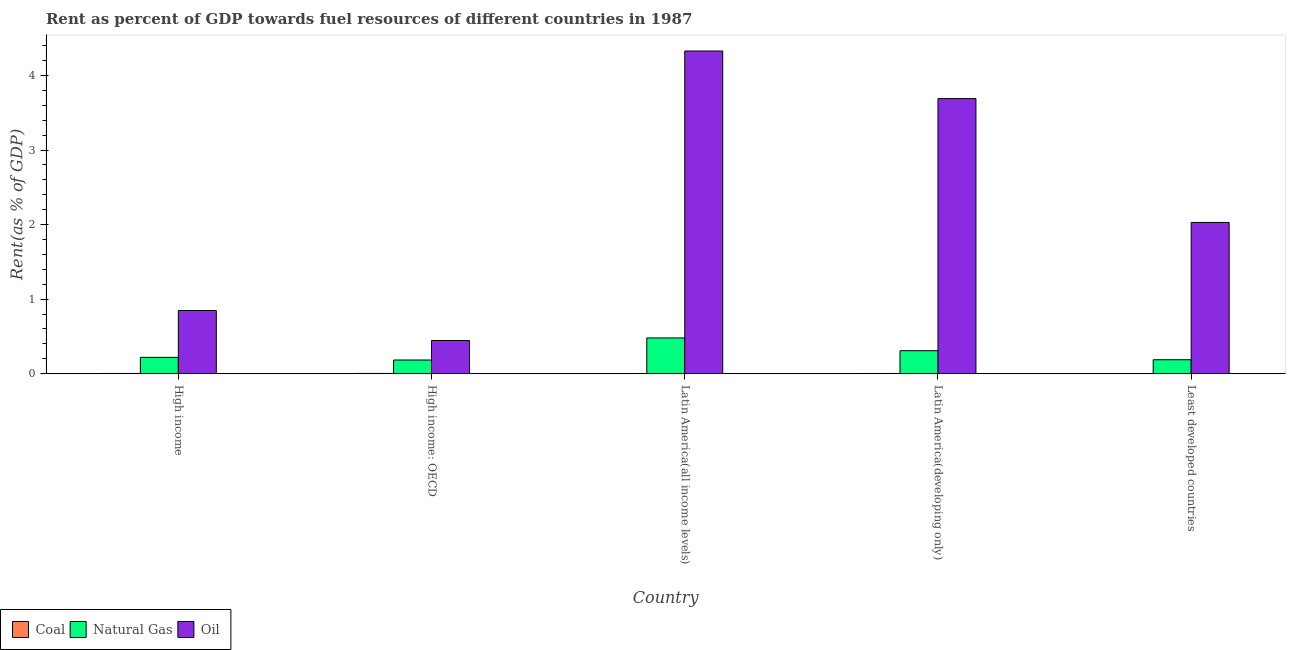How many groups of bars are there?
Your answer should be compact. 5. What is the label of the 2nd group of bars from the left?
Provide a succinct answer. High income: OECD. In how many cases, is the number of bars for a given country not equal to the number of legend labels?
Keep it short and to the point. 0. What is the rent towards natural gas in Least developed countries?
Ensure brevity in your answer.  0.19. Across all countries, what is the maximum rent towards coal?
Give a very brief answer. 0. Across all countries, what is the minimum rent towards natural gas?
Offer a terse response. 0.18. In which country was the rent towards natural gas maximum?
Make the answer very short. Latin America(all income levels). In which country was the rent towards oil minimum?
Offer a terse response. High income: OECD. What is the total rent towards natural gas in the graph?
Provide a short and direct response. 1.38. What is the difference between the rent towards coal in High income and that in High income: OECD?
Your response must be concise. -0. What is the difference between the rent towards coal in Latin America(developing only) and the rent towards natural gas in High income?
Your answer should be compact. -0.22. What is the average rent towards natural gas per country?
Make the answer very short. 0.28. What is the difference between the rent towards coal and rent towards oil in Latin America(all income levels)?
Ensure brevity in your answer.  -4.33. In how many countries, is the rent towards oil greater than 1.2 %?
Give a very brief answer. 3. What is the ratio of the rent towards natural gas in High income to that in High income: OECD?
Your answer should be compact. 1.19. Is the difference between the rent towards oil in High income and Latin America(all income levels) greater than the difference between the rent towards coal in High income and Latin America(all income levels)?
Make the answer very short. No. What is the difference between the highest and the second highest rent towards oil?
Provide a short and direct response. 0.64. What is the difference between the highest and the lowest rent towards oil?
Your answer should be compact. 3.88. In how many countries, is the rent towards oil greater than the average rent towards oil taken over all countries?
Make the answer very short. 2. What does the 1st bar from the left in High income: OECD represents?
Keep it short and to the point. Coal. What does the 1st bar from the right in High income: OECD represents?
Provide a succinct answer. Oil. Is it the case that in every country, the sum of the rent towards coal and rent towards natural gas is greater than the rent towards oil?
Offer a terse response. No. How many bars are there?
Your response must be concise. 15. How many countries are there in the graph?
Give a very brief answer. 5. Does the graph contain any zero values?
Ensure brevity in your answer.  No. Where does the legend appear in the graph?
Ensure brevity in your answer.  Bottom left. How are the legend labels stacked?
Give a very brief answer. Horizontal. What is the title of the graph?
Provide a short and direct response. Rent as percent of GDP towards fuel resources of different countries in 1987. Does "Czech Republic" appear as one of the legend labels in the graph?
Offer a terse response. No. What is the label or title of the X-axis?
Offer a terse response. Country. What is the label or title of the Y-axis?
Provide a short and direct response. Rent(as % of GDP). What is the Rent(as % of GDP) in Coal in High income?
Provide a short and direct response. 0. What is the Rent(as % of GDP) in Natural Gas in High income?
Make the answer very short. 0.22. What is the Rent(as % of GDP) of Oil in High income?
Give a very brief answer. 0.85. What is the Rent(as % of GDP) in Coal in High income: OECD?
Your response must be concise. 0. What is the Rent(as % of GDP) of Natural Gas in High income: OECD?
Give a very brief answer. 0.18. What is the Rent(as % of GDP) of Oil in High income: OECD?
Make the answer very short. 0.45. What is the Rent(as % of GDP) in Coal in Latin America(all income levels)?
Your response must be concise. 0. What is the Rent(as % of GDP) of Natural Gas in Latin America(all income levels)?
Keep it short and to the point. 0.48. What is the Rent(as % of GDP) of Oil in Latin America(all income levels)?
Provide a short and direct response. 4.33. What is the Rent(as % of GDP) of Coal in Latin America(developing only)?
Give a very brief answer. 0. What is the Rent(as % of GDP) of Natural Gas in Latin America(developing only)?
Keep it short and to the point. 0.31. What is the Rent(as % of GDP) of Oil in Latin America(developing only)?
Ensure brevity in your answer.  3.69. What is the Rent(as % of GDP) of Coal in Least developed countries?
Your answer should be compact. 5.84697420507121e-6. What is the Rent(as % of GDP) in Natural Gas in Least developed countries?
Ensure brevity in your answer.  0.19. What is the Rent(as % of GDP) of Oil in Least developed countries?
Your answer should be compact. 2.03. Across all countries, what is the maximum Rent(as % of GDP) in Coal?
Your response must be concise. 0. Across all countries, what is the maximum Rent(as % of GDP) of Natural Gas?
Ensure brevity in your answer.  0.48. Across all countries, what is the maximum Rent(as % of GDP) in Oil?
Your response must be concise. 4.33. Across all countries, what is the minimum Rent(as % of GDP) in Coal?
Offer a terse response. 5.84697420507121e-6. Across all countries, what is the minimum Rent(as % of GDP) of Natural Gas?
Your answer should be compact. 0.18. Across all countries, what is the minimum Rent(as % of GDP) in Oil?
Offer a very short reply. 0.45. What is the total Rent(as % of GDP) of Coal in the graph?
Ensure brevity in your answer.  0.01. What is the total Rent(as % of GDP) of Natural Gas in the graph?
Your answer should be compact. 1.38. What is the total Rent(as % of GDP) in Oil in the graph?
Your response must be concise. 11.34. What is the difference between the Rent(as % of GDP) in Coal in High income and that in High income: OECD?
Make the answer very short. -0. What is the difference between the Rent(as % of GDP) of Natural Gas in High income and that in High income: OECD?
Give a very brief answer. 0.04. What is the difference between the Rent(as % of GDP) of Oil in High income and that in High income: OECD?
Keep it short and to the point. 0.4. What is the difference between the Rent(as % of GDP) of Coal in High income and that in Latin America(all income levels)?
Give a very brief answer. 0. What is the difference between the Rent(as % of GDP) of Natural Gas in High income and that in Latin America(all income levels)?
Your answer should be very brief. -0.26. What is the difference between the Rent(as % of GDP) in Oil in High income and that in Latin America(all income levels)?
Your answer should be compact. -3.48. What is the difference between the Rent(as % of GDP) of Natural Gas in High income and that in Latin America(developing only)?
Your response must be concise. -0.09. What is the difference between the Rent(as % of GDP) in Oil in High income and that in Latin America(developing only)?
Keep it short and to the point. -2.84. What is the difference between the Rent(as % of GDP) of Coal in High income and that in Least developed countries?
Offer a very short reply. 0. What is the difference between the Rent(as % of GDP) in Natural Gas in High income and that in Least developed countries?
Keep it short and to the point. 0.03. What is the difference between the Rent(as % of GDP) in Oil in High income and that in Least developed countries?
Offer a terse response. -1.18. What is the difference between the Rent(as % of GDP) in Coal in High income: OECD and that in Latin America(all income levels)?
Keep it short and to the point. 0. What is the difference between the Rent(as % of GDP) in Natural Gas in High income: OECD and that in Latin America(all income levels)?
Your response must be concise. -0.3. What is the difference between the Rent(as % of GDP) of Oil in High income: OECD and that in Latin America(all income levels)?
Make the answer very short. -3.88. What is the difference between the Rent(as % of GDP) of Coal in High income: OECD and that in Latin America(developing only)?
Keep it short and to the point. 0. What is the difference between the Rent(as % of GDP) of Natural Gas in High income: OECD and that in Latin America(developing only)?
Ensure brevity in your answer.  -0.12. What is the difference between the Rent(as % of GDP) of Oil in High income: OECD and that in Latin America(developing only)?
Your answer should be compact. -3.24. What is the difference between the Rent(as % of GDP) of Coal in High income: OECD and that in Least developed countries?
Give a very brief answer. 0. What is the difference between the Rent(as % of GDP) of Natural Gas in High income: OECD and that in Least developed countries?
Your answer should be very brief. -0. What is the difference between the Rent(as % of GDP) of Oil in High income: OECD and that in Least developed countries?
Your response must be concise. -1.58. What is the difference between the Rent(as % of GDP) in Coal in Latin America(all income levels) and that in Latin America(developing only)?
Offer a very short reply. -0. What is the difference between the Rent(as % of GDP) of Natural Gas in Latin America(all income levels) and that in Latin America(developing only)?
Offer a terse response. 0.17. What is the difference between the Rent(as % of GDP) in Oil in Latin America(all income levels) and that in Latin America(developing only)?
Offer a terse response. 0.64. What is the difference between the Rent(as % of GDP) of Coal in Latin America(all income levels) and that in Least developed countries?
Your answer should be compact. 0. What is the difference between the Rent(as % of GDP) of Natural Gas in Latin America(all income levels) and that in Least developed countries?
Your answer should be compact. 0.29. What is the difference between the Rent(as % of GDP) of Oil in Latin America(all income levels) and that in Least developed countries?
Provide a succinct answer. 2.3. What is the difference between the Rent(as % of GDP) of Coal in Latin America(developing only) and that in Least developed countries?
Give a very brief answer. 0. What is the difference between the Rent(as % of GDP) in Natural Gas in Latin America(developing only) and that in Least developed countries?
Ensure brevity in your answer.  0.12. What is the difference between the Rent(as % of GDP) in Oil in Latin America(developing only) and that in Least developed countries?
Your response must be concise. 1.66. What is the difference between the Rent(as % of GDP) in Coal in High income and the Rent(as % of GDP) in Natural Gas in High income: OECD?
Your answer should be very brief. -0.18. What is the difference between the Rent(as % of GDP) of Coal in High income and the Rent(as % of GDP) of Oil in High income: OECD?
Your answer should be compact. -0.44. What is the difference between the Rent(as % of GDP) of Natural Gas in High income and the Rent(as % of GDP) of Oil in High income: OECD?
Your response must be concise. -0.23. What is the difference between the Rent(as % of GDP) of Coal in High income and the Rent(as % of GDP) of Natural Gas in Latin America(all income levels)?
Keep it short and to the point. -0.48. What is the difference between the Rent(as % of GDP) of Coal in High income and the Rent(as % of GDP) of Oil in Latin America(all income levels)?
Give a very brief answer. -4.32. What is the difference between the Rent(as % of GDP) of Natural Gas in High income and the Rent(as % of GDP) of Oil in Latin America(all income levels)?
Offer a very short reply. -4.11. What is the difference between the Rent(as % of GDP) of Coal in High income and the Rent(as % of GDP) of Natural Gas in Latin America(developing only)?
Provide a succinct answer. -0.3. What is the difference between the Rent(as % of GDP) in Coal in High income and the Rent(as % of GDP) in Oil in Latin America(developing only)?
Offer a very short reply. -3.69. What is the difference between the Rent(as % of GDP) in Natural Gas in High income and the Rent(as % of GDP) in Oil in Latin America(developing only)?
Provide a succinct answer. -3.47. What is the difference between the Rent(as % of GDP) in Coal in High income and the Rent(as % of GDP) in Natural Gas in Least developed countries?
Keep it short and to the point. -0.18. What is the difference between the Rent(as % of GDP) in Coal in High income and the Rent(as % of GDP) in Oil in Least developed countries?
Your answer should be compact. -2.03. What is the difference between the Rent(as % of GDP) in Natural Gas in High income and the Rent(as % of GDP) in Oil in Least developed countries?
Ensure brevity in your answer.  -1.81. What is the difference between the Rent(as % of GDP) in Coal in High income: OECD and the Rent(as % of GDP) in Natural Gas in Latin America(all income levels)?
Provide a short and direct response. -0.48. What is the difference between the Rent(as % of GDP) of Coal in High income: OECD and the Rent(as % of GDP) of Oil in Latin America(all income levels)?
Your answer should be very brief. -4.32. What is the difference between the Rent(as % of GDP) in Natural Gas in High income: OECD and the Rent(as % of GDP) in Oil in Latin America(all income levels)?
Ensure brevity in your answer.  -4.14. What is the difference between the Rent(as % of GDP) in Coal in High income: OECD and the Rent(as % of GDP) in Natural Gas in Latin America(developing only)?
Keep it short and to the point. -0.3. What is the difference between the Rent(as % of GDP) of Coal in High income: OECD and the Rent(as % of GDP) of Oil in Latin America(developing only)?
Offer a very short reply. -3.69. What is the difference between the Rent(as % of GDP) in Natural Gas in High income: OECD and the Rent(as % of GDP) in Oil in Latin America(developing only)?
Provide a succinct answer. -3.51. What is the difference between the Rent(as % of GDP) in Coal in High income: OECD and the Rent(as % of GDP) in Natural Gas in Least developed countries?
Provide a short and direct response. -0.18. What is the difference between the Rent(as % of GDP) in Coal in High income: OECD and the Rent(as % of GDP) in Oil in Least developed countries?
Ensure brevity in your answer.  -2.02. What is the difference between the Rent(as % of GDP) in Natural Gas in High income: OECD and the Rent(as % of GDP) in Oil in Least developed countries?
Offer a terse response. -1.84. What is the difference between the Rent(as % of GDP) in Coal in Latin America(all income levels) and the Rent(as % of GDP) in Natural Gas in Latin America(developing only)?
Offer a terse response. -0.31. What is the difference between the Rent(as % of GDP) of Coal in Latin America(all income levels) and the Rent(as % of GDP) of Oil in Latin America(developing only)?
Your answer should be very brief. -3.69. What is the difference between the Rent(as % of GDP) of Natural Gas in Latin America(all income levels) and the Rent(as % of GDP) of Oil in Latin America(developing only)?
Keep it short and to the point. -3.21. What is the difference between the Rent(as % of GDP) of Coal in Latin America(all income levels) and the Rent(as % of GDP) of Natural Gas in Least developed countries?
Your answer should be very brief. -0.19. What is the difference between the Rent(as % of GDP) of Coal in Latin America(all income levels) and the Rent(as % of GDP) of Oil in Least developed countries?
Your answer should be very brief. -2.03. What is the difference between the Rent(as % of GDP) in Natural Gas in Latin America(all income levels) and the Rent(as % of GDP) in Oil in Least developed countries?
Ensure brevity in your answer.  -1.55. What is the difference between the Rent(as % of GDP) in Coal in Latin America(developing only) and the Rent(as % of GDP) in Natural Gas in Least developed countries?
Provide a short and direct response. -0.18. What is the difference between the Rent(as % of GDP) in Coal in Latin America(developing only) and the Rent(as % of GDP) in Oil in Least developed countries?
Offer a very short reply. -2.03. What is the difference between the Rent(as % of GDP) of Natural Gas in Latin America(developing only) and the Rent(as % of GDP) of Oil in Least developed countries?
Offer a terse response. -1.72. What is the average Rent(as % of GDP) of Coal per country?
Provide a succinct answer. 0. What is the average Rent(as % of GDP) of Natural Gas per country?
Provide a short and direct response. 0.28. What is the average Rent(as % of GDP) in Oil per country?
Offer a terse response. 2.27. What is the difference between the Rent(as % of GDP) in Coal and Rent(as % of GDP) in Natural Gas in High income?
Give a very brief answer. -0.22. What is the difference between the Rent(as % of GDP) of Coal and Rent(as % of GDP) of Oil in High income?
Keep it short and to the point. -0.84. What is the difference between the Rent(as % of GDP) of Natural Gas and Rent(as % of GDP) of Oil in High income?
Give a very brief answer. -0.63. What is the difference between the Rent(as % of GDP) in Coal and Rent(as % of GDP) in Natural Gas in High income: OECD?
Make the answer very short. -0.18. What is the difference between the Rent(as % of GDP) of Coal and Rent(as % of GDP) of Oil in High income: OECD?
Ensure brevity in your answer.  -0.44. What is the difference between the Rent(as % of GDP) in Natural Gas and Rent(as % of GDP) in Oil in High income: OECD?
Your response must be concise. -0.26. What is the difference between the Rent(as % of GDP) in Coal and Rent(as % of GDP) in Natural Gas in Latin America(all income levels)?
Ensure brevity in your answer.  -0.48. What is the difference between the Rent(as % of GDP) in Coal and Rent(as % of GDP) in Oil in Latin America(all income levels)?
Offer a very short reply. -4.33. What is the difference between the Rent(as % of GDP) in Natural Gas and Rent(as % of GDP) in Oil in Latin America(all income levels)?
Your answer should be compact. -3.85. What is the difference between the Rent(as % of GDP) in Coal and Rent(as % of GDP) in Natural Gas in Latin America(developing only)?
Offer a very short reply. -0.31. What is the difference between the Rent(as % of GDP) of Coal and Rent(as % of GDP) of Oil in Latin America(developing only)?
Provide a succinct answer. -3.69. What is the difference between the Rent(as % of GDP) in Natural Gas and Rent(as % of GDP) in Oil in Latin America(developing only)?
Offer a terse response. -3.38. What is the difference between the Rent(as % of GDP) of Coal and Rent(as % of GDP) of Natural Gas in Least developed countries?
Keep it short and to the point. -0.19. What is the difference between the Rent(as % of GDP) of Coal and Rent(as % of GDP) of Oil in Least developed countries?
Provide a succinct answer. -2.03. What is the difference between the Rent(as % of GDP) of Natural Gas and Rent(as % of GDP) of Oil in Least developed countries?
Keep it short and to the point. -1.84. What is the ratio of the Rent(as % of GDP) in Coal in High income to that in High income: OECD?
Your answer should be very brief. 0.96. What is the ratio of the Rent(as % of GDP) in Natural Gas in High income to that in High income: OECD?
Offer a terse response. 1.19. What is the ratio of the Rent(as % of GDP) of Oil in High income to that in High income: OECD?
Make the answer very short. 1.9. What is the ratio of the Rent(as % of GDP) in Coal in High income to that in Latin America(all income levels)?
Provide a succinct answer. 1.57. What is the ratio of the Rent(as % of GDP) of Natural Gas in High income to that in Latin America(all income levels)?
Provide a succinct answer. 0.46. What is the ratio of the Rent(as % of GDP) of Oil in High income to that in Latin America(all income levels)?
Your response must be concise. 0.2. What is the ratio of the Rent(as % of GDP) of Coal in High income to that in Latin America(developing only)?
Provide a short and direct response. 1.14. What is the ratio of the Rent(as % of GDP) in Natural Gas in High income to that in Latin America(developing only)?
Your response must be concise. 0.71. What is the ratio of the Rent(as % of GDP) in Oil in High income to that in Latin America(developing only)?
Provide a short and direct response. 0.23. What is the ratio of the Rent(as % of GDP) of Coal in High income to that in Least developed countries?
Your answer should be very brief. 668.19. What is the ratio of the Rent(as % of GDP) of Natural Gas in High income to that in Least developed countries?
Provide a succinct answer. 1.17. What is the ratio of the Rent(as % of GDP) of Oil in High income to that in Least developed countries?
Your response must be concise. 0.42. What is the ratio of the Rent(as % of GDP) of Coal in High income: OECD to that in Latin America(all income levels)?
Your response must be concise. 1.64. What is the ratio of the Rent(as % of GDP) in Natural Gas in High income: OECD to that in Latin America(all income levels)?
Give a very brief answer. 0.38. What is the ratio of the Rent(as % of GDP) of Oil in High income: OECD to that in Latin America(all income levels)?
Provide a succinct answer. 0.1. What is the ratio of the Rent(as % of GDP) of Coal in High income: OECD to that in Latin America(developing only)?
Ensure brevity in your answer.  1.19. What is the ratio of the Rent(as % of GDP) in Natural Gas in High income: OECD to that in Latin America(developing only)?
Your response must be concise. 0.6. What is the ratio of the Rent(as % of GDP) in Oil in High income: OECD to that in Latin America(developing only)?
Give a very brief answer. 0.12. What is the ratio of the Rent(as % of GDP) in Coal in High income: OECD to that in Least developed countries?
Give a very brief answer. 695.39. What is the ratio of the Rent(as % of GDP) of Oil in High income: OECD to that in Least developed countries?
Your response must be concise. 0.22. What is the ratio of the Rent(as % of GDP) in Coal in Latin America(all income levels) to that in Latin America(developing only)?
Your answer should be compact. 0.73. What is the ratio of the Rent(as % of GDP) of Natural Gas in Latin America(all income levels) to that in Latin America(developing only)?
Provide a short and direct response. 1.55. What is the ratio of the Rent(as % of GDP) of Oil in Latin America(all income levels) to that in Latin America(developing only)?
Offer a very short reply. 1.17. What is the ratio of the Rent(as % of GDP) in Coal in Latin America(all income levels) to that in Least developed countries?
Your answer should be very brief. 425.18. What is the ratio of the Rent(as % of GDP) in Natural Gas in Latin America(all income levels) to that in Least developed countries?
Give a very brief answer. 2.56. What is the ratio of the Rent(as % of GDP) in Oil in Latin America(all income levels) to that in Least developed countries?
Your answer should be very brief. 2.13. What is the ratio of the Rent(as % of GDP) of Coal in Latin America(developing only) to that in Least developed countries?
Your answer should be compact. 585.97. What is the ratio of the Rent(as % of GDP) in Natural Gas in Latin America(developing only) to that in Least developed countries?
Ensure brevity in your answer.  1.64. What is the ratio of the Rent(as % of GDP) in Oil in Latin America(developing only) to that in Least developed countries?
Give a very brief answer. 1.82. What is the difference between the highest and the second highest Rent(as % of GDP) in Coal?
Your answer should be compact. 0. What is the difference between the highest and the second highest Rent(as % of GDP) in Natural Gas?
Offer a very short reply. 0.17. What is the difference between the highest and the second highest Rent(as % of GDP) in Oil?
Provide a succinct answer. 0.64. What is the difference between the highest and the lowest Rent(as % of GDP) of Coal?
Provide a short and direct response. 0. What is the difference between the highest and the lowest Rent(as % of GDP) in Natural Gas?
Keep it short and to the point. 0.3. What is the difference between the highest and the lowest Rent(as % of GDP) in Oil?
Give a very brief answer. 3.88. 